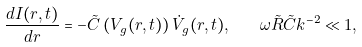Convert formula to latex. <formula><loc_0><loc_0><loc_500><loc_500>\frac { d I ( r , t ) } { d r } = - \tilde { C } \left ( V _ { g } ( r , t ) \right ) \dot { V } _ { g } ( r , t ) , \quad \omega \tilde { R } \tilde { C } k ^ { - 2 } \ll 1 ,</formula> 